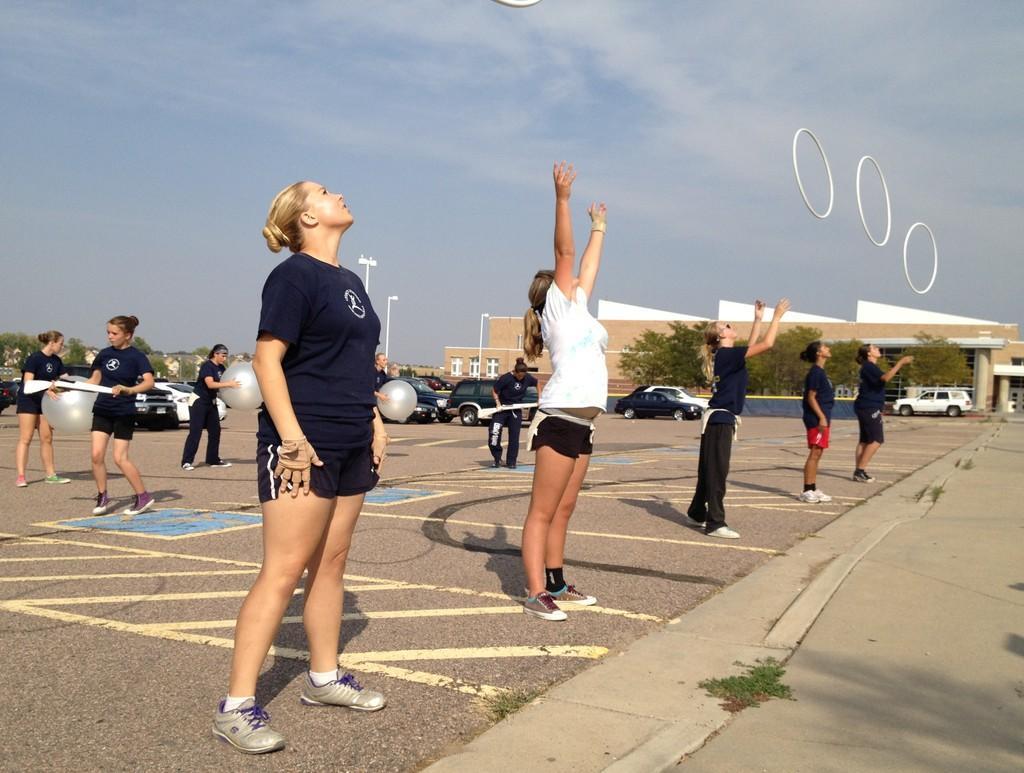In one or two sentences, can you explain what this image depicts? In the center of the image we can see a buildings, trees, cars, trucks and some persons are there. At the top of the image sky is present. At the bottom of the image ground is there. 